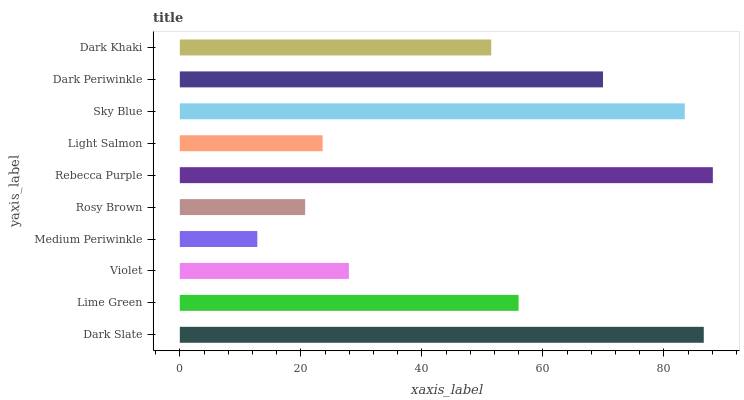Is Medium Periwinkle the minimum?
Answer yes or no. Yes. Is Rebecca Purple the maximum?
Answer yes or no. Yes. Is Lime Green the minimum?
Answer yes or no. No. Is Lime Green the maximum?
Answer yes or no. No. Is Dark Slate greater than Lime Green?
Answer yes or no. Yes. Is Lime Green less than Dark Slate?
Answer yes or no. Yes. Is Lime Green greater than Dark Slate?
Answer yes or no. No. Is Dark Slate less than Lime Green?
Answer yes or no. No. Is Lime Green the high median?
Answer yes or no. Yes. Is Dark Khaki the low median?
Answer yes or no. Yes. Is Medium Periwinkle the high median?
Answer yes or no. No. Is Dark Periwinkle the low median?
Answer yes or no. No. 